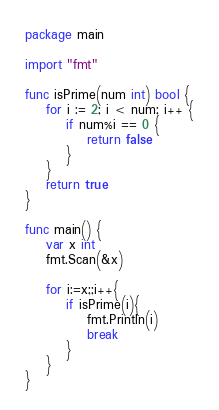<code> <loc_0><loc_0><loc_500><loc_500><_Go_>package main

import "fmt"

func isPrime(num int) bool {
	for i := 2; i < num; i++ {
		if num%i == 0 {
			return false
		}
	}
	return true
}

func main() {
	var x int
	fmt.Scan(&x)

	for i:=x;;i++{
		if isPrime(i){
			fmt.Println(i)
			break
		}
	}
}</code> 